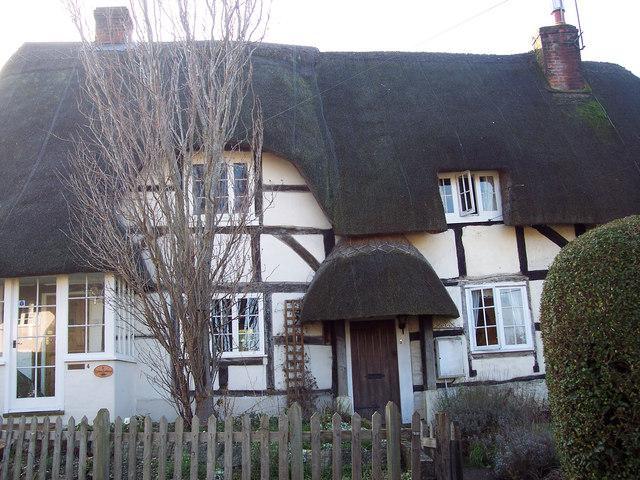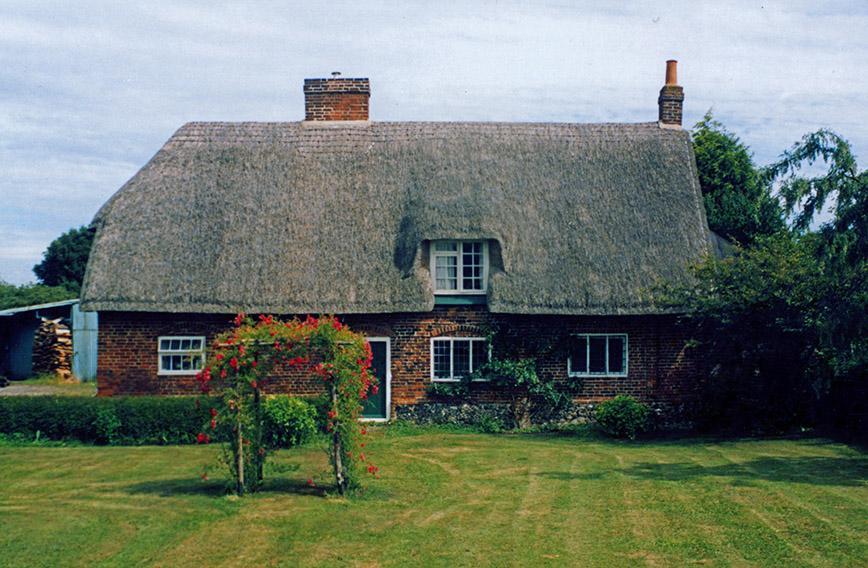The first image is the image on the left, the second image is the image on the right. For the images shown, is this caption "There is a house with a thatch roof with two dormered windows, the home has a dark colored door and black lines on the front of the home" true? Answer yes or no. Yes. The first image is the image on the left, the second image is the image on the right. Examine the images to the left and right. Is the description "In at least one image there is a house with exposed wood planks about a white front door." accurate? Answer yes or no. No. 